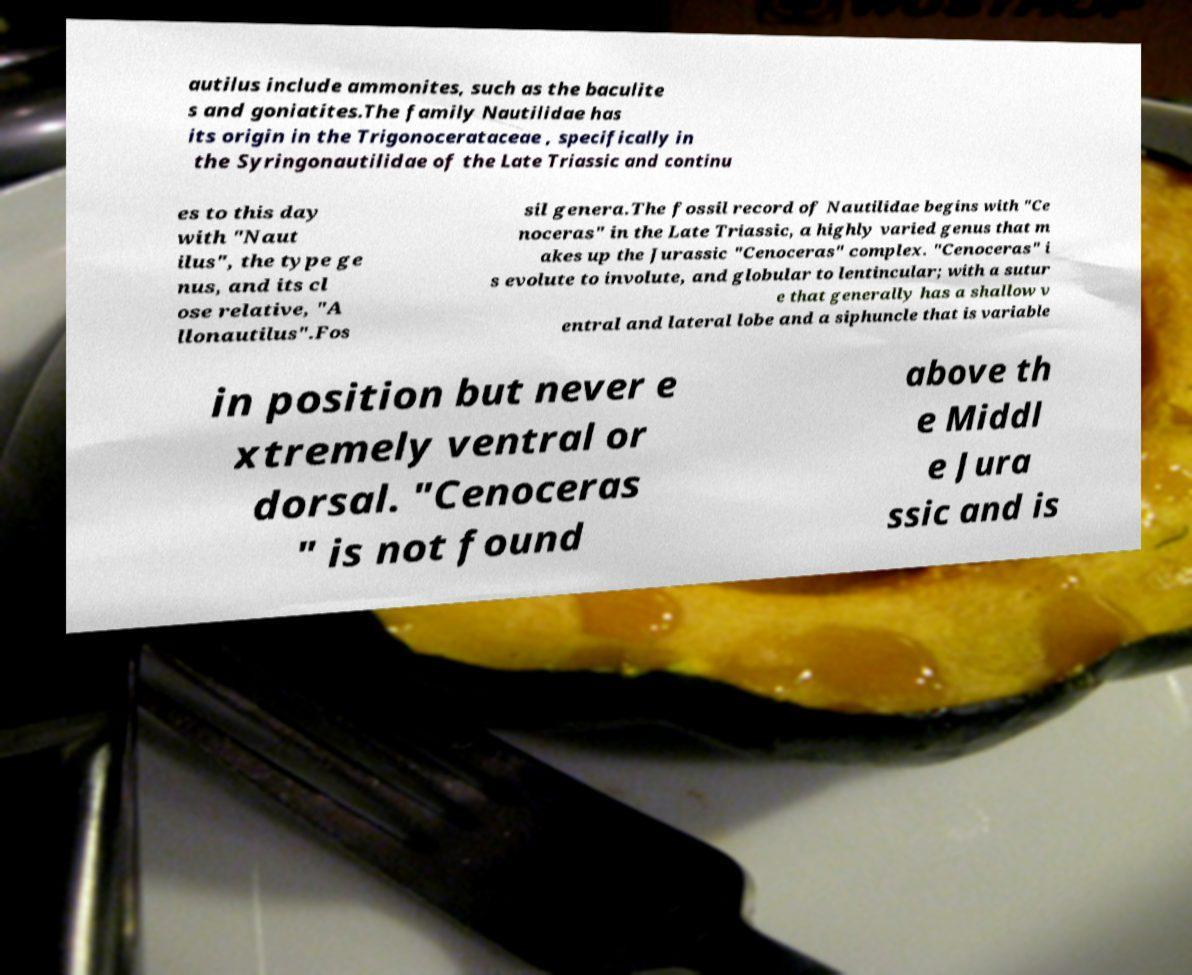Could you extract and type out the text from this image? autilus include ammonites, such as the baculite s and goniatites.The family Nautilidae has its origin in the Trigonocerataceae , specifically in the Syringonautilidae of the Late Triassic and continu es to this day with "Naut ilus", the type ge nus, and its cl ose relative, "A llonautilus".Fos sil genera.The fossil record of Nautilidae begins with "Ce noceras" in the Late Triassic, a highly varied genus that m akes up the Jurassic "Cenoceras" complex. "Cenoceras" i s evolute to involute, and globular to lentincular; with a sutur e that generally has a shallow v entral and lateral lobe and a siphuncle that is variable in position but never e xtremely ventral or dorsal. "Cenoceras " is not found above th e Middl e Jura ssic and is 